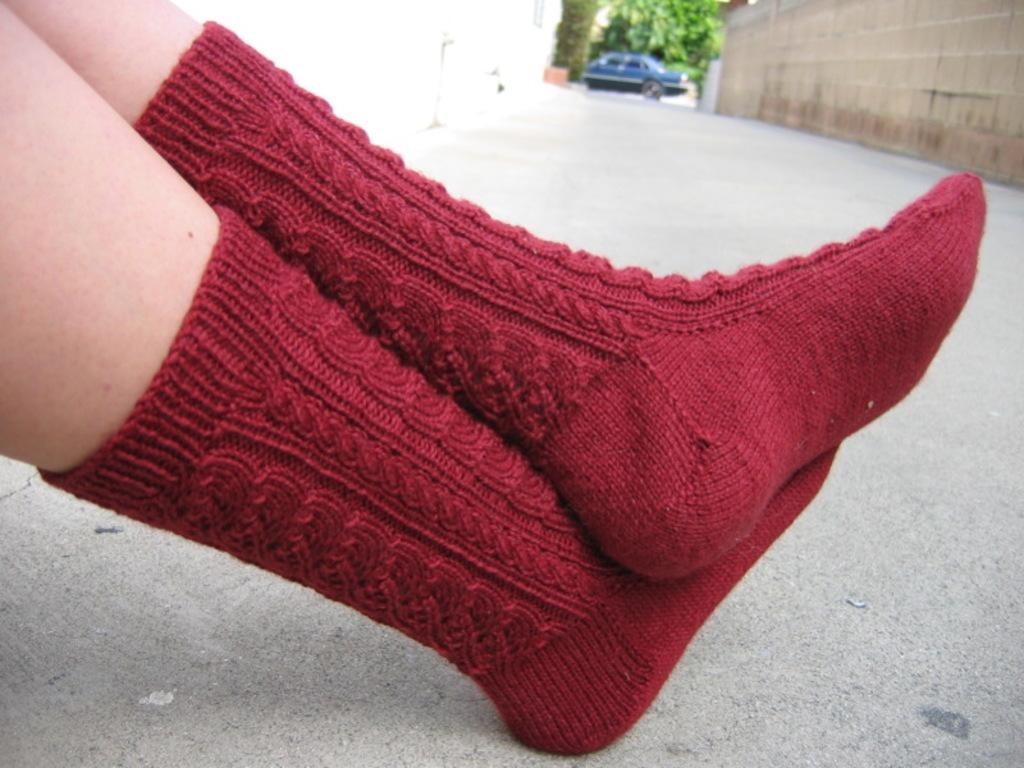What can be seen on the person's leg in the image? There is a person's leg with red socks in the image. What type of pathway is visible in the image? There is a road in the image. What is located in the background of the image? There is a wall, a car, and a tree in the background of the image. What type of lumber is being used by the spy in the image? There is no lumber or spy present in the image. What type of work is the person with red socks doing in the image? The image does not provide information about the person's activity or occupation. 